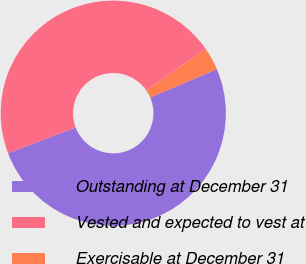Convert chart to OTSL. <chart><loc_0><loc_0><loc_500><loc_500><pie_chart><fcel>Outstanding at December 31<fcel>Vested and expected to vest at<fcel>Exercisable at December 31<nl><fcel>50.61%<fcel>46.11%<fcel>3.28%<nl></chart> 